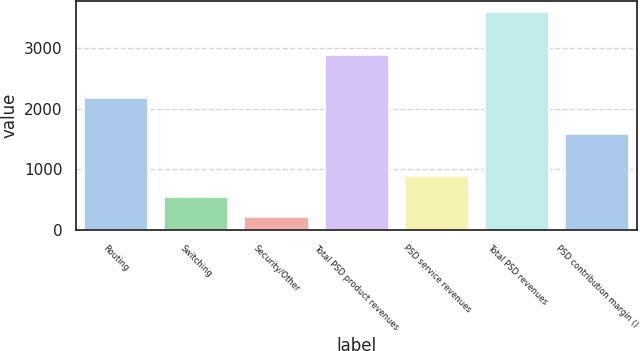Convert chart. <chart><loc_0><loc_0><loc_500><loc_500><bar_chart><fcel>Routing<fcel>Switching<fcel>Security/Other<fcel>Total PSD product revenues<fcel>PSD service revenues<fcel>Total PSD revenues<fcel>PSD contribution margin ()<nl><fcel>2166<fcel>550.71<fcel>213.2<fcel>2875<fcel>888.22<fcel>3588.3<fcel>1586.2<nl></chart> 